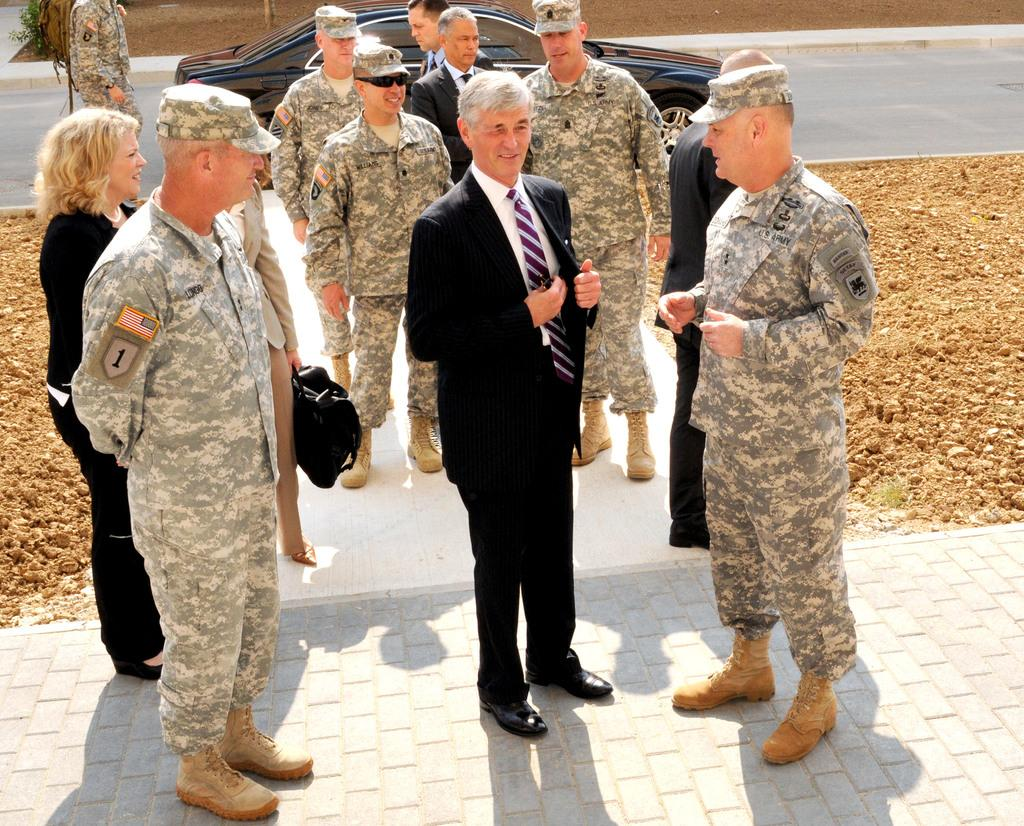What are the people in the image doing? The people in the image are standing on a path. What can be seen in the background of the image? There is a car on a road in the background of the image. Who is near the car in the background? There is a man standing near the car in the background of the image. What type of surface is on either side of the path? There is soil on either side of the path in the image. What type of calculator is being used by the people on the path in the image? There is no calculator present in the image; the people are simply standing on the path. How does friction affect the movement of the people on the path in the image? The provided facts do not mention friction or its effects on the people's movement in the image. 